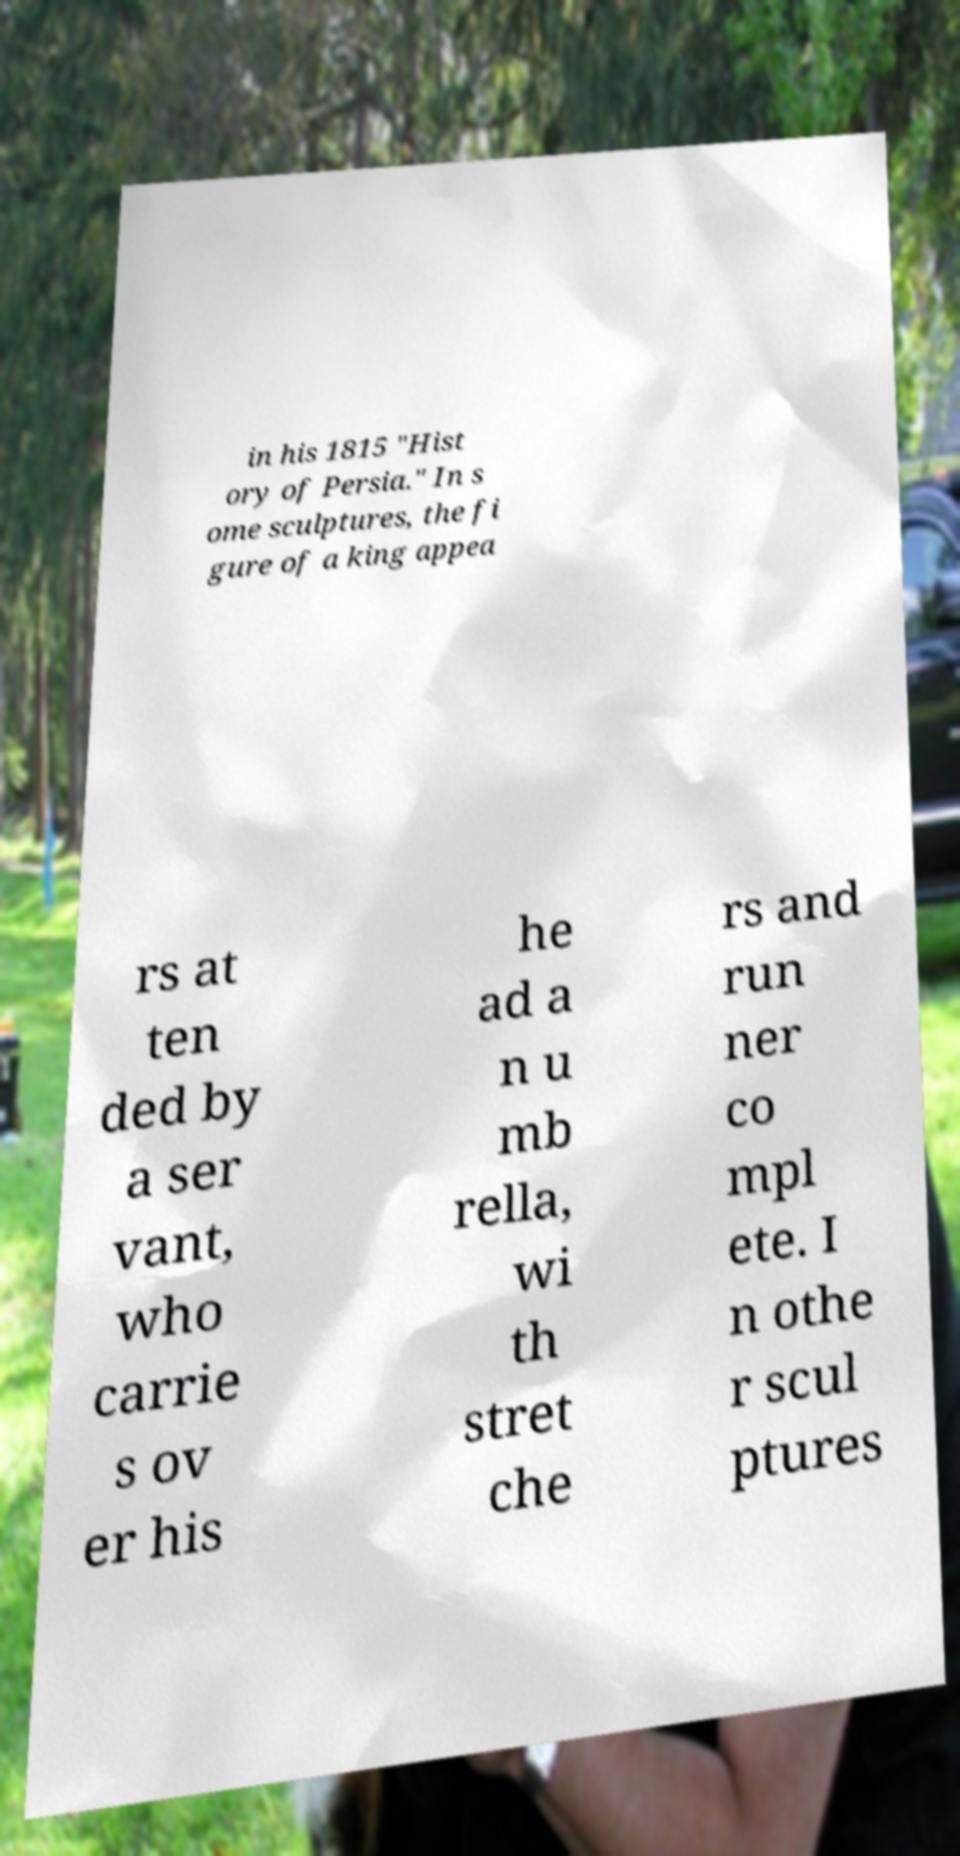Can you read and provide the text displayed in the image?This photo seems to have some interesting text. Can you extract and type it out for me? in his 1815 "Hist ory of Persia." In s ome sculptures, the fi gure of a king appea rs at ten ded by a ser vant, who carrie s ov er his he ad a n u mb rella, wi th stret che rs and run ner co mpl ete. I n othe r scul ptures 